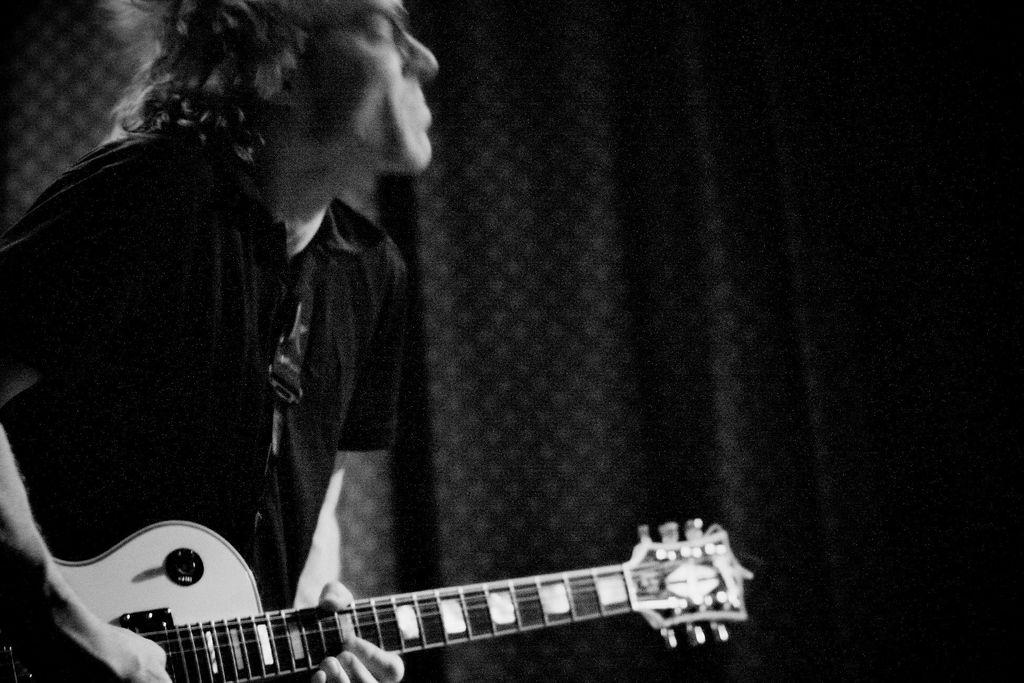Who is in the image? There is a boy in the image. What is the boy holding? The boy is holding a music instrument. What can be seen in the background of the image? There is a black color curtain in the background. What is the curtain covering? The curtain is covering a wall. Can you see any cords attached to the music instrument in the image? There is no mention of cords in the provided facts, so we cannot determine if any are present in the image. Is there a nest visible in the image? There is no mention of a nest in the provided facts, so we cannot determine if one is present in the image. 